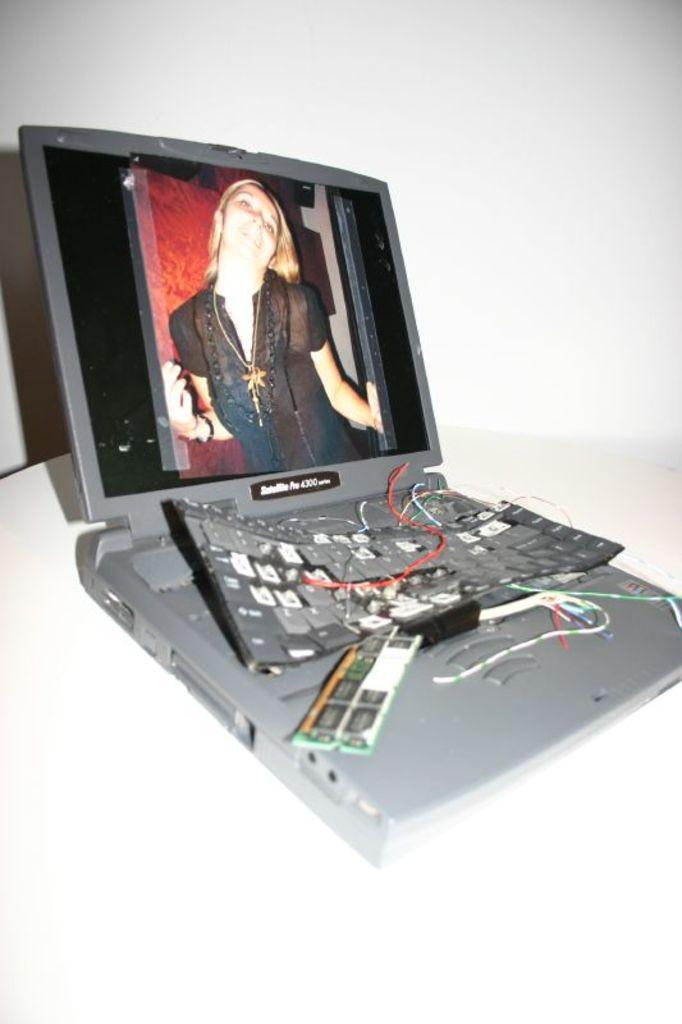What electronic device is present in the image? There is a laptop in the image. What is the condition of the laptop? The laptop is broken. What can be seen on the laptop screen? There is a woman's picture on the laptop screen. What type of disease is the laptop suffering from in the image? The laptop is not suffering from a disease; it is broken. Who is the manager of the stream in the image? There is no stream or manager present in the image. 